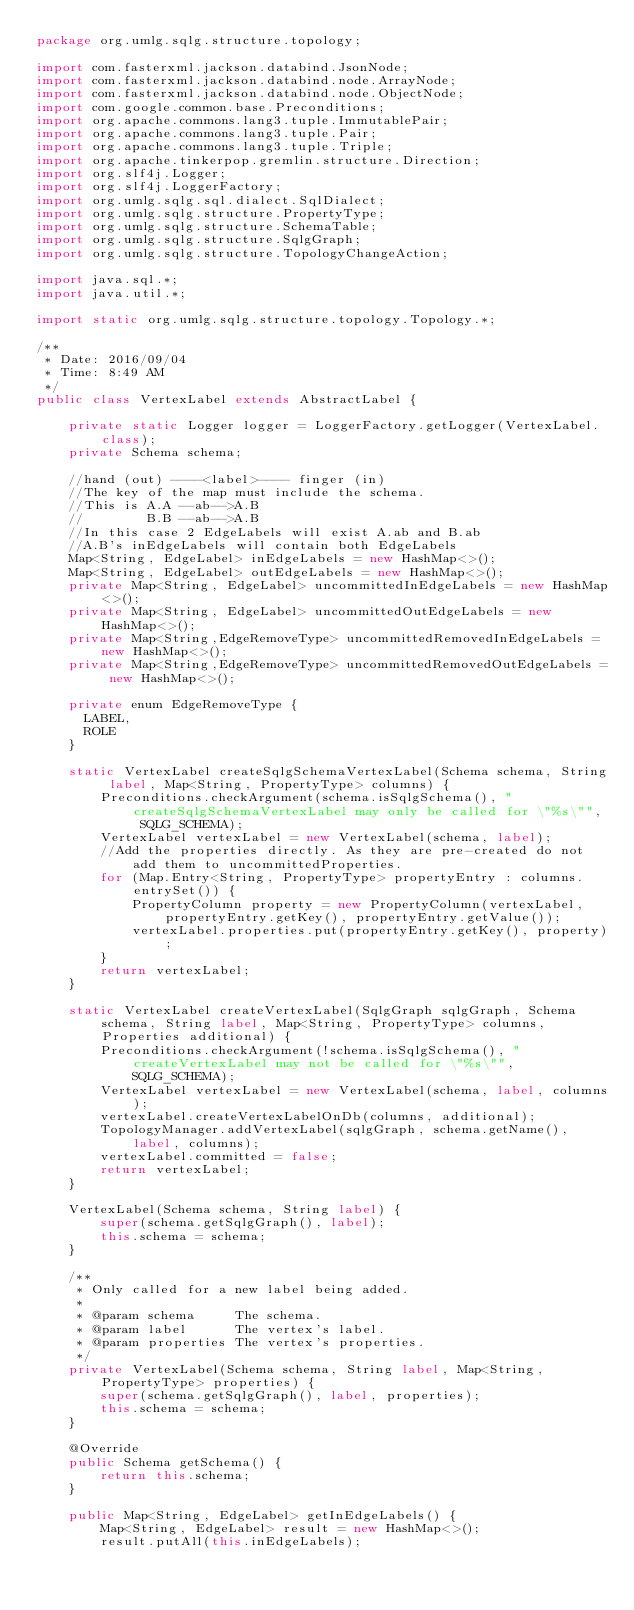<code> <loc_0><loc_0><loc_500><loc_500><_Java_>package org.umlg.sqlg.structure.topology;

import com.fasterxml.jackson.databind.JsonNode;
import com.fasterxml.jackson.databind.node.ArrayNode;
import com.fasterxml.jackson.databind.node.ObjectNode;
import com.google.common.base.Preconditions;
import org.apache.commons.lang3.tuple.ImmutablePair;
import org.apache.commons.lang3.tuple.Pair;
import org.apache.commons.lang3.tuple.Triple;
import org.apache.tinkerpop.gremlin.structure.Direction;
import org.slf4j.Logger;
import org.slf4j.LoggerFactory;
import org.umlg.sqlg.sql.dialect.SqlDialect;
import org.umlg.sqlg.structure.PropertyType;
import org.umlg.sqlg.structure.SchemaTable;
import org.umlg.sqlg.structure.SqlgGraph;
import org.umlg.sqlg.structure.TopologyChangeAction;

import java.sql.*;
import java.util.*;

import static org.umlg.sqlg.structure.topology.Topology.*;

/**
 * Date: 2016/09/04
 * Time: 8:49 AM
 */
public class VertexLabel extends AbstractLabel {

    private static Logger logger = LoggerFactory.getLogger(VertexLabel.class);
    private Schema schema;

    //hand (out) ----<label>---- finger (in)
    //The key of the map must include the schema.
    //This is A.A --ab-->A.B
    //        B.B --ab-->A.B
    //In this case 2 EdgeLabels will exist A.ab and B.ab
    //A.B's inEdgeLabels will contain both EdgeLabels
    Map<String, EdgeLabel> inEdgeLabels = new HashMap<>();
    Map<String, EdgeLabel> outEdgeLabels = new HashMap<>();
    private Map<String, EdgeLabel> uncommittedInEdgeLabels = new HashMap<>();
    private Map<String, EdgeLabel> uncommittedOutEdgeLabels = new HashMap<>();
    private Map<String,EdgeRemoveType> uncommittedRemovedInEdgeLabels = new HashMap<>();
    private Map<String,EdgeRemoveType> uncommittedRemovedOutEdgeLabels = new HashMap<>();
    
    private enum EdgeRemoveType {
    	LABEL,
    	ROLE
    }
    
    static VertexLabel createSqlgSchemaVertexLabel(Schema schema, String label, Map<String, PropertyType> columns) {
        Preconditions.checkArgument(schema.isSqlgSchema(), "createSqlgSchemaVertexLabel may only be called for \"%s\"", SQLG_SCHEMA);
        VertexLabel vertexLabel = new VertexLabel(schema, label);
        //Add the properties directly. As they are pre-created do not add them to uncommittedProperties.
        for (Map.Entry<String, PropertyType> propertyEntry : columns.entrySet()) {
            PropertyColumn property = new PropertyColumn(vertexLabel, propertyEntry.getKey(), propertyEntry.getValue());
            vertexLabel.properties.put(propertyEntry.getKey(), property);
        }
        return vertexLabel;
    }

    static VertexLabel createVertexLabel(SqlgGraph sqlgGraph, Schema schema, String label, Map<String, PropertyType> columns, Properties additional) {
        Preconditions.checkArgument(!schema.isSqlgSchema(), "createVertexLabel may not be called for \"%s\"", SQLG_SCHEMA);
        VertexLabel vertexLabel = new VertexLabel(schema, label, columns);
        vertexLabel.createVertexLabelOnDb(columns, additional);
        TopologyManager.addVertexLabel(sqlgGraph, schema.getName(), label, columns);
        vertexLabel.committed = false;
        return vertexLabel;
    }

    VertexLabel(Schema schema, String label) {
        super(schema.getSqlgGraph(), label);
        this.schema = schema;
    }

    /**
     * Only called for a new label being added.
     *
     * @param schema     The schema.
     * @param label      The vertex's label.
     * @param properties The vertex's properties.
     */
    private VertexLabel(Schema schema, String label, Map<String, PropertyType> properties) {
        super(schema.getSqlgGraph(), label, properties);
        this.schema = schema;
    }

    @Override
    public Schema getSchema() {
        return this.schema;
    }

    public Map<String, EdgeLabel> getInEdgeLabels() {
        Map<String, EdgeLabel> result = new HashMap<>();
        result.putAll(this.inEdgeLabels);</code> 